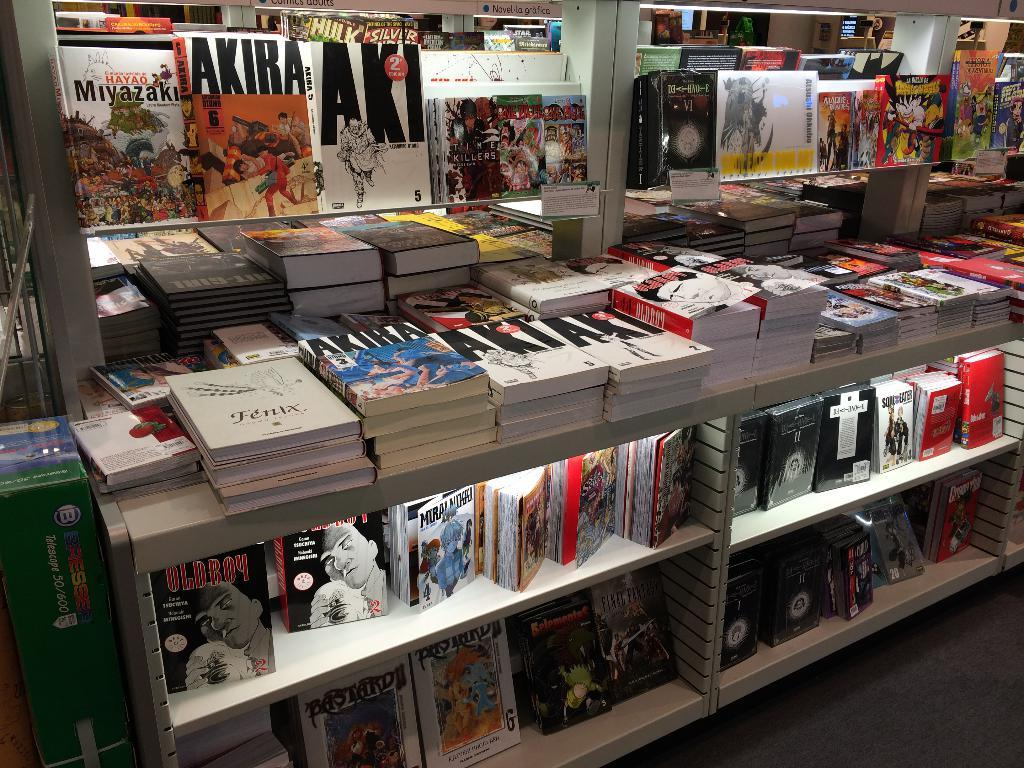<image>
Summarize the visual content of the image. Book store with a book titled Fenix in the front. 